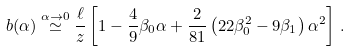<formula> <loc_0><loc_0><loc_500><loc_500>b ( \alpha ) \stackrel { \alpha \to 0 } { \simeq } \frac { \ell } { z } \left [ 1 - \frac { 4 } { 9 } \beta _ { 0 } \alpha + \frac { 2 } { 8 1 } \left ( 2 2 \beta _ { 0 } ^ { 2 } - 9 \beta _ { 1 } \right ) \alpha ^ { 2 } \right ] \, .</formula> 